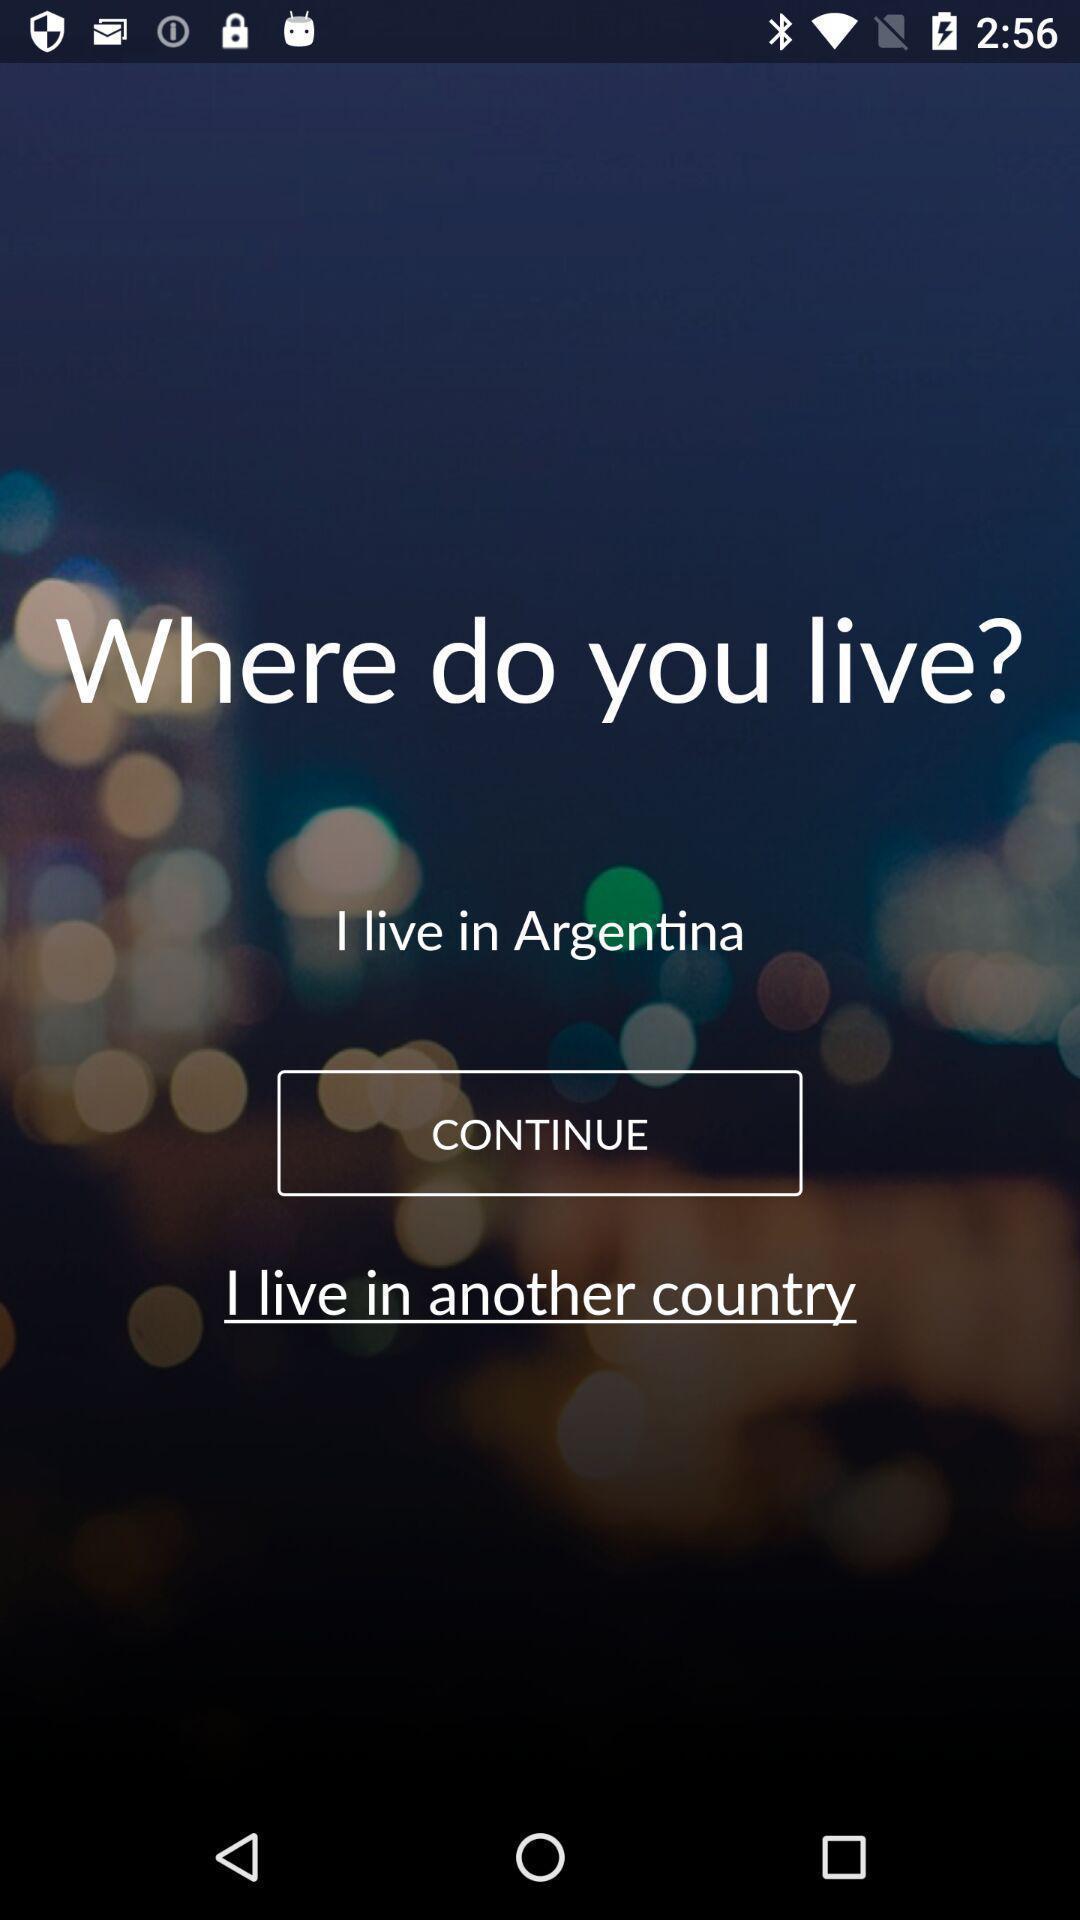Give me a narrative description of this picture. Welcome page of a social app. 